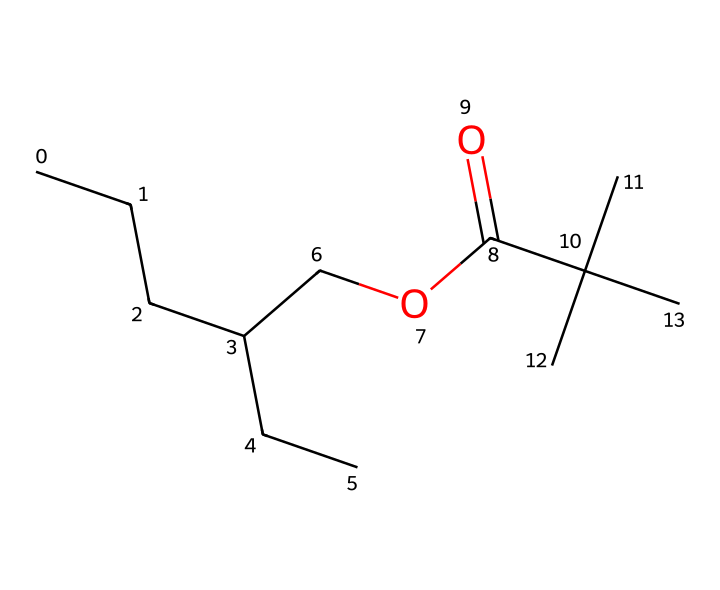What is the total number of carbon atoms in this chemical? By analyzing the SMILES representation, we can count the number of carbon atoms represented by the letter 'C'. There are 12 carbons present in the structure.
Answer: 12 How many oxygen atoms are present in this lipid structure? The SMILES representation has 'O' which indicates oxygen atoms. In this case, the structure has 2 oxygen atoms.
Answer: 2 What functional group is present in this chemical? Examining the structure, the presence of 'COC(=O)' indicates the presence of an ester functional group. The 'C(=O)' part signals the carbonyl and the 'O' connected to another carbon suggests it's an ester.
Answer: ester What is the molecular formula of the chemical? By combining the counted atoms from the SMILES, comprising of 12 carbons (C), 22 hydrogens (H), and 2 oxygens (O), gives the formula C12H22O2.
Answer: C12H22O2 Given the structure, what type of lipid could this compound represent? The long carbon chain and the ester functional group suggest that this compound is likely a triglyceride or fatty acid derivative, common in lipid structures.
Answer: triglyceride What characteristic of this lipid structure makes it suitable for thermal management in EV batteries? The presence of long carbon chains, which are typical in lipids, indicates hydrophobic properties allowing for good thermal stability and heat transfer efficiency, crucial for battery performance.
Answer: hydrophobic properties Does this lipid structure contain any double bonds? Assessing the SMILES representation, there are no double bond indicators (such as 'C=C') present, confirming that this structure is saturated.
Answer: no 